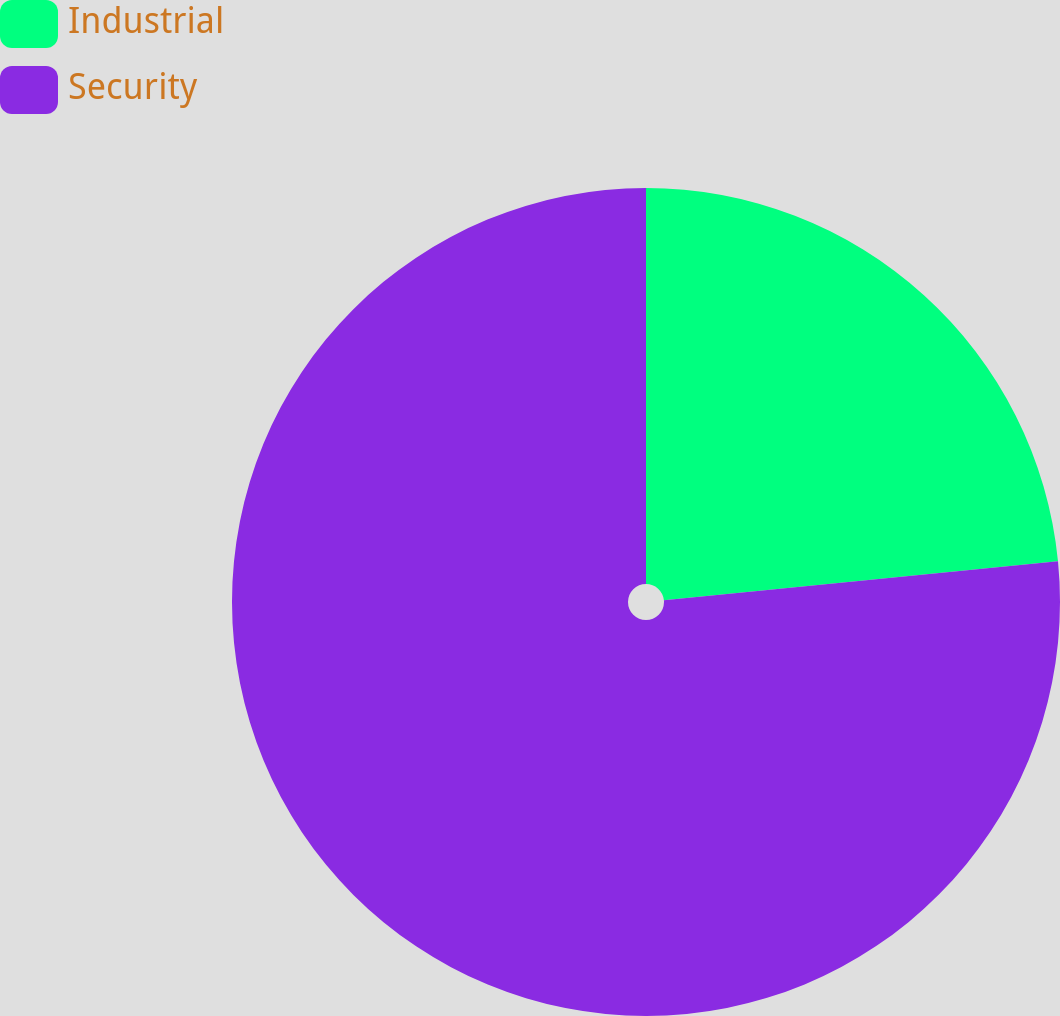<chart> <loc_0><loc_0><loc_500><loc_500><pie_chart><fcel>Industrial<fcel>Security<nl><fcel>23.43%<fcel>76.57%<nl></chart> 